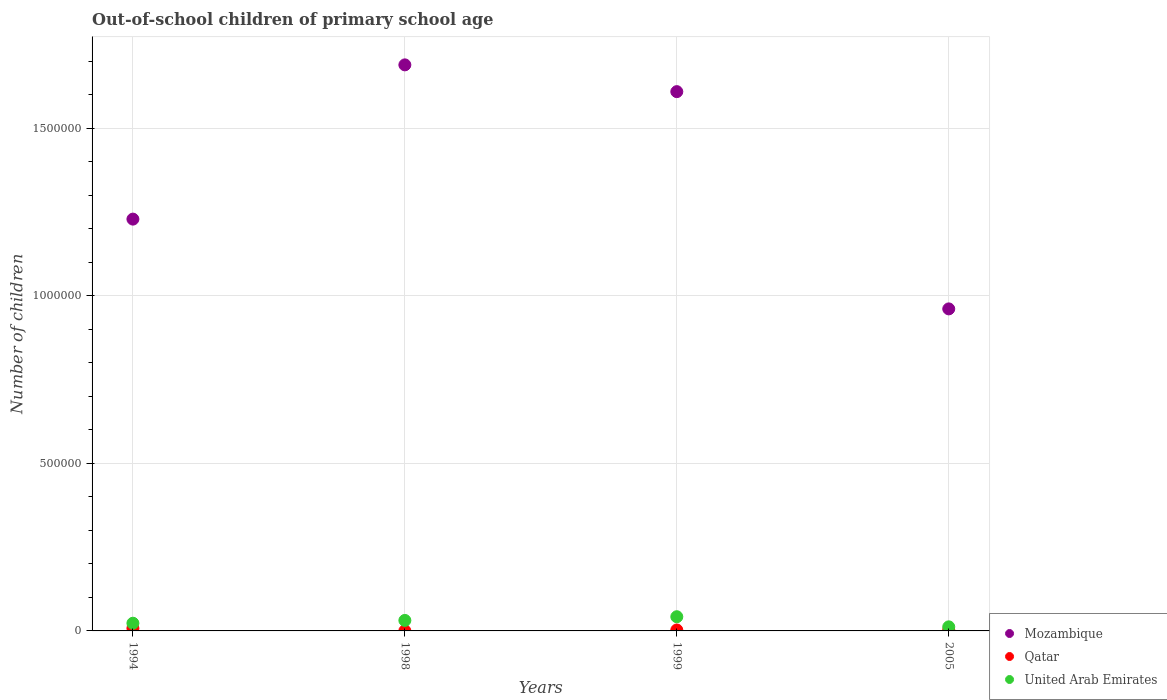Is the number of dotlines equal to the number of legend labels?
Keep it short and to the point. Yes. What is the number of out-of-school children in Mozambique in 1999?
Give a very brief answer. 1.61e+06. Across all years, what is the maximum number of out-of-school children in Mozambique?
Your response must be concise. 1.69e+06. Across all years, what is the minimum number of out-of-school children in United Arab Emirates?
Keep it short and to the point. 1.22e+04. In which year was the number of out-of-school children in Mozambique maximum?
Provide a succinct answer. 1998. What is the total number of out-of-school children in Qatar in the graph?
Provide a short and direct response. 1.37e+04. What is the difference between the number of out-of-school children in Mozambique in 1999 and that in 2005?
Your response must be concise. 6.48e+05. What is the difference between the number of out-of-school children in Qatar in 1994 and the number of out-of-school children in United Arab Emirates in 2005?
Make the answer very short. -4436. What is the average number of out-of-school children in United Arab Emirates per year?
Offer a terse response. 2.72e+04. In the year 1998, what is the difference between the number of out-of-school children in United Arab Emirates and number of out-of-school children in Qatar?
Provide a succinct answer. 3.09e+04. In how many years, is the number of out-of-school children in United Arab Emirates greater than 400000?
Provide a short and direct response. 0. What is the ratio of the number of out-of-school children in Mozambique in 1994 to that in 1998?
Provide a short and direct response. 0.73. Is the number of out-of-school children in Mozambique in 1998 less than that in 1999?
Provide a short and direct response. No. Is the difference between the number of out-of-school children in United Arab Emirates in 1998 and 2005 greater than the difference between the number of out-of-school children in Qatar in 1998 and 2005?
Provide a succinct answer. Yes. What is the difference between the highest and the second highest number of out-of-school children in Mozambique?
Your response must be concise. 7.99e+04. What is the difference between the highest and the lowest number of out-of-school children in Mozambique?
Your response must be concise. 7.28e+05. Is the number of out-of-school children in Qatar strictly greater than the number of out-of-school children in Mozambique over the years?
Offer a terse response. No. What is the difference between two consecutive major ticks on the Y-axis?
Your response must be concise. 5.00e+05. Does the graph contain any zero values?
Your answer should be compact. No. Does the graph contain grids?
Offer a terse response. Yes. What is the title of the graph?
Offer a very short reply. Out-of-school children of primary school age. Does "Somalia" appear as one of the legend labels in the graph?
Provide a succinct answer. No. What is the label or title of the Y-axis?
Offer a terse response. Number of children. What is the Number of children of Mozambique in 1994?
Give a very brief answer. 1.23e+06. What is the Number of children in Qatar in 1994?
Give a very brief answer. 7729. What is the Number of children of United Arab Emirates in 1994?
Provide a succinct answer. 2.30e+04. What is the Number of children in Mozambique in 1998?
Provide a short and direct response. 1.69e+06. What is the Number of children in Qatar in 1998?
Make the answer very short. 385. What is the Number of children in United Arab Emirates in 1998?
Make the answer very short. 3.13e+04. What is the Number of children in Mozambique in 1999?
Your answer should be compact. 1.61e+06. What is the Number of children of Qatar in 1999?
Provide a succinct answer. 2820. What is the Number of children of United Arab Emirates in 1999?
Offer a very short reply. 4.24e+04. What is the Number of children in Mozambique in 2005?
Offer a terse response. 9.61e+05. What is the Number of children of Qatar in 2005?
Provide a short and direct response. 2782. What is the Number of children in United Arab Emirates in 2005?
Give a very brief answer. 1.22e+04. Across all years, what is the maximum Number of children of Mozambique?
Keep it short and to the point. 1.69e+06. Across all years, what is the maximum Number of children in Qatar?
Provide a succinct answer. 7729. Across all years, what is the maximum Number of children in United Arab Emirates?
Make the answer very short. 4.24e+04. Across all years, what is the minimum Number of children in Mozambique?
Offer a terse response. 9.61e+05. Across all years, what is the minimum Number of children in Qatar?
Provide a short and direct response. 385. Across all years, what is the minimum Number of children in United Arab Emirates?
Your response must be concise. 1.22e+04. What is the total Number of children of Mozambique in the graph?
Your answer should be compact. 5.49e+06. What is the total Number of children of Qatar in the graph?
Provide a succinct answer. 1.37e+04. What is the total Number of children of United Arab Emirates in the graph?
Keep it short and to the point. 1.09e+05. What is the difference between the Number of children in Mozambique in 1994 and that in 1998?
Give a very brief answer. -4.60e+05. What is the difference between the Number of children in Qatar in 1994 and that in 1998?
Provide a succinct answer. 7344. What is the difference between the Number of children of United Arab Emirates in 1994 and that in 1998?
Offer a terse response. -8369. What is the difference between the Number of children in Mozambique in 1994 and that in 1999?
Your response must be concise. -3.80e+05. What is the difference between the Number of children of Qatar in 1994 and that in 1999?
Your response must be concise. 4909. What is the difference between the Number of children in United Arab Emirates in 1994 and that in 1999?
Offer a very short reply. -1.94e+04. What is the difference between the Number of children in Mozambique in 1994 and that in 2005?
Ensure brevity in your answer.  2.68e+05. What is the difference between the Number of children of Qatar in 1994 and that in 2005?
Provide a short and direct response. 4947. What is the difference between the Number of children in United Arab Emirates in 1994 and that in 2005?
Provide a short and direct response. 1.08e+04. What is the difference between the Number of children in Mozambique in 1998 and that in 1999?
Make the answer very short. 7.99e+04. What is the difference between the Number of children of Qatar in 1998 and that in 1999?
Your answer should be compact. -2435. What is the difference between the Number of children of United Arab Emirates in 1998 and that in 1999?
Your response must be concise. -1.10e+04. What is the difference between the Number of children of Mozambique in 1998 and that in 2005?
Your answer should be compact. 7.28e+05. What is the difference between the Number of children of Qatar in 1998 and that in 2005?
Ensure brevity in your answer.  -2397. What is the difference between the Number of children of United Arab Emirates in 1998 and that in 2005?
Offer a terse response. 1.92e+04. What is the difference between the Number of children of Mozambique in 1999 and that in 2005?
Provide a succinct answer. 6.48e+05. What is the difference between the Number of children of United Arab Emirates in 1999 and that in 2005?
Your answer should be compact. 3.02e+04. What is the difference between the Number of children in Mozambique in 1994 and the Number of children in Qatar in 1998?
Offer a terse response. 1.23e+06. What is the difference between the Number of children in Mozambique in 1994 and the Number of children in United Arab Emirates in 1998?
Provide a short and direct response. 1.20e+06. What is the difference between the Number of children of Qatar in 1994 and the Number of children of United Arab Emirates in 1998?
Ensure brevity in your answer.  -2.36e+04. What is the difference between the Number of children of Mozambique in 1994 and the Number of children of Qatar in 1999?
Give a very brief answer. 1.23e+06. What is the difference between the Number of children of Mozambique in 1994 and the Number of children of United Arab Emirates in 1999?
Your answer should be compact. 1.19e+06. What is the difference between the Number of children of Qatar in 1994 and the Number of children of United Arab Emirates in 1999?
Your answer should be very brief. -3.46e+04. What is the difference between the Number of children of Mozambique in 1994 and the Number of children of Qatar in 2005?
Your response must be concise. 1.23e+06. What is the difference between the Number of children in Mozambique in 1994 and the Number of children in United Arab Emirates in 2005?
Provide a succinct answer. 1.22e+06. What is the difference between the Number of children in Qatar in 1994 and the Number of children in United Arab Emirates in 2005?
Your response must be concise. -4436. What is the difference between the Number of children of Mozambique in 1998 and the Number of children of Qatar in 1999?
Ensure brevity in your answer.  1.69e+06. What is the difference between the Number of children in Mozambique in 1998 and the Number of children in United Arab Emirates in 1999?
Your answer should be very brief. 1.65e+06. What is the difference between the Number of children of Qatar in 1998 and the Number of children of United Arab Emirates in 1999?
Your response must be concise. -4.20e+04. What is the difference between the Number of children of Mozambique in 1998 and the Number of children of Qatar in 2005?
Provide a succinct answer. 1.69e+06. What is the difference between the Number of children of Mozambique in 1998 and the Number of children of United Arab Emirates in 2005?
Provide a short and direct response. 1.68e+06. What is the difference between the Number of children in Qatar in 1998 and the Number of children in United Arab Emirates in 2005?
Make the answer very short. -1.18e+04. What is the difference between the Number of children of Mozambique in 1999 and the Number of children of Qatar in 2005?
Keep it short and to the point. 1.61e+06. What is the difference between the Number of children in Mozambique in 1999 and the Number of children in United Arab Emirates in 2005?
Your answer should be very brief. 1.60e+06. What is the difference between the Number of children of Qatar in 1999 and the Number of children of United Arab Emirates in 2005?
Provide a succinct answer. -9345. What is the average Number of children of Mozambique per year?
Offer a terse response. 1.37e+06. What is the average Number of children in Qatar per year?
Keep it short and to the point. 3429. What is the average Number of children of United Arab Emirates per year?
Provide a short and direct response. 2.72e+04. In the year 1994, what is the difference between the Number of children in Mozambique and Number of children in Qatar?
Provide a short and direct response. 1.22e+06. In the year 1994, what is the difference between the Number of children of Mozambique and Number of children of United Arab Emirates?
Provide a succinct answer. 1.21e+06. In the year 1994, what is the difference between the Number of children in Qatar and Number of children in United Arab Emirates?
Provide a succinct answer. -1.52e+04. In the year 1998, what is the difference between the Number of children of Mozambique and Number of children of Qatar?
Offer a very short reply. 1.69e+06. In the year 1998, what is the difference between the Number of children of Mozambique and Number of children of United Arab Emirates?
Make the answer very short. 1.66e+06. In the year 1998, what is the difference between the Number of children in Qatar and Number of children in United Arab Emirates?
Keep it short and to the point. -3.09e+04. In the year 1999, what is the difference between the Number of children in Mozambique and Number of children in Qatar?
Your answer should be compact. 1.61e+06. In the year 1999, what is the difference between the Number of children in Mozambique and Number of children in United Arab Emirates?
Your answer should be compact. 1.57e+06. In the year 1999, what is the difference between the Number of children of Qatar and Number of children of United Arab Emirates?
Offer a very short reply. -3.95e+04. In the year 2005, what is the difference between the Number of children in Mozambique and Number of children in Qatar?
Your response must be concise. 9.58e+05. In the year 2005, what is the difference between the Number of children in Mozambique and Number of children in United Arab Emirates?
Your response must be concise. 9.49e+05. In the year 2005, what is the difference between the Number of children of Qatar and Number of children of United Arab Emirates?
Provide a short and direct response. -9383. What is the ratio of the Number of children of Mozambique in 1994 to that in 1998?
Give a very brief answer. 0.73. What is the ratio of the Number of children of Qatar in 1994 to that in 1998?
Provide a short and direct response. 20.08. What is the ratio of the Number of children in United Arab Emirates in 1994 to that in 1998?
Your answer should be compact. 0.73. What is the ratio of the Number of children in Mozambique in 1994 to that in 1999?
Offer a terse response. 0.76. What is the ratio of the Number of children of Qatar in 1994 to that in 1999?
Your answer should be very brief. 2.74. What is the ratio of the Number of children of United Arab Emirates in 1994 to that in 1999?
Your answer should be compact. 0.54. What is the ratio of the Number of children of Mozambique in 1994 to that in 2005?
Ensure brevity in your answer.  1.28. What is the ratio of the Number of children of Qatar in 1994 to that in 2005?
Make the answer very short. 2.78. What is the ratio of the Number of children of United Arab Emirates in 1994 to that in 2005?
Provide a succinct answer. 1.89. What is the ratio of the Number of children of Mozambique in 1998 to that in 1999?
Offer a very short reply. 1.05. What is the ratio of the Number of children of Qatar in 1998 to that in 1999?
Keep it short and to the point. 0.14. What is the ratio of the Number of children in United Arab Emirates in 1998 to that in 1999?
Give a very brief answer. 0.74. What is the ratio of the Number of children in Mozambique in 1998 to that in 2005?
Make the answer very short. 1.76. What is the ratio of the Number of children in Qatar in 1998 to that in 2005?
Make the answer very short. 0.14. What is the ratio of the Number of children of United Arab Emirates in 1998 to that in 2005?
Ensure brevity in your answer.  2.58. What is the ratio of the Number of children of Mozambique in 1999 to that in 2005?
Ensure brevity in your answer.  1.67. What is the ratio of the Number of children in Qatar in 1999 to that in 2005?
Your answer should be compact. 1.01. What is the ratio of the Number of children of United Arab Emirates in 1999 to that in 2005?
Provide a succinct answer. 3.48. What is the difference between the highest and the second highest Number of children of Mozambique?
Your response must be concise. 7.99e+04. What is the difference between the highest and the second highest Number of children of Qatar?
Offer a very short reply. 4909. What is the difference between the highest and the second highest Number of children of United Arab Emirates?
Keep it short and to the point. 1.10e+04. What is the difference between the highest and the lowest Number of children of Mozambique?
Offer a very short reply. 7.28e+05. What is the difference between the highest and the lowest Number of children of Qatar?
Provide a succinct answer. 7344. What is the difference between the highest and the lowest Number of children in United Arab Emirates?
Provide a short and direct response. 3.02e+04. 